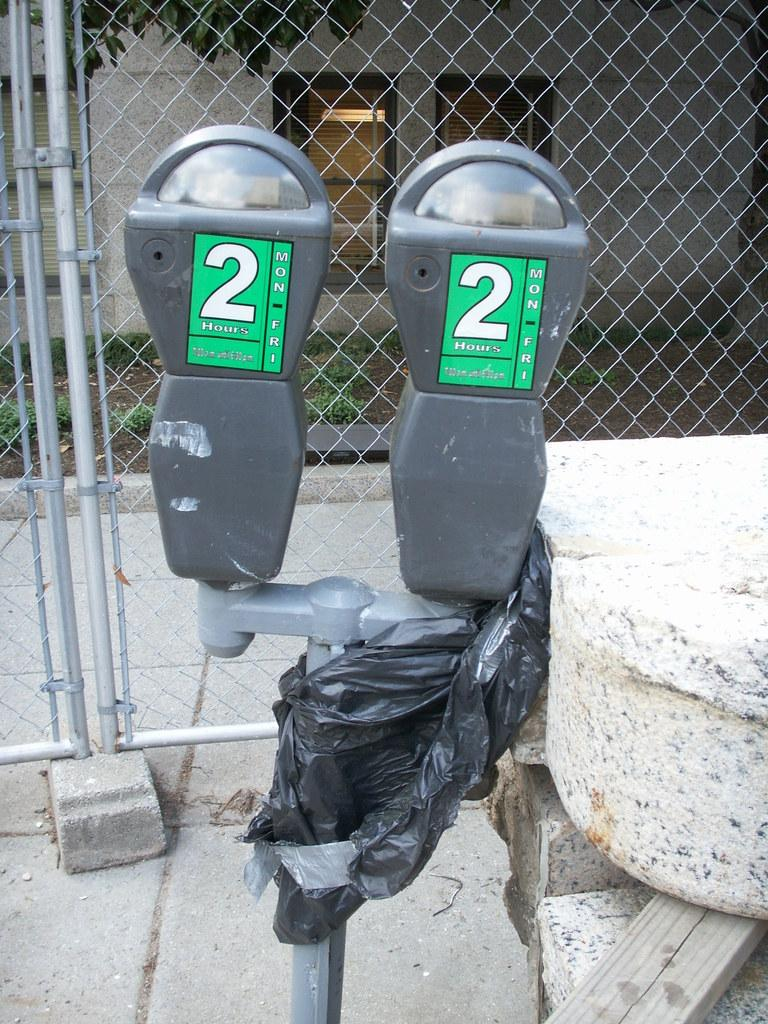<image>
Present a compact description of the photo's key features. a set of two parking meters that have 2 hours and Mon to Fri on them. 